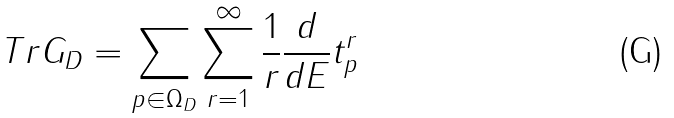<formula> <loc_0><loc_0><loc_500><loc_500>T r G _ { D } = \sum _ { p \in \Omega _ { D } } \sum _ { r = 1 } ^ { \infty } \frac { 1 } { r } \frac { d } { d E } t _ { p } ^ { r }</formula> 